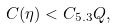<formula> <loc_0><loc_0><loc_500><loc_500>C ( \eta ) < C _ { 5 . 3 } Q ,</formula> 